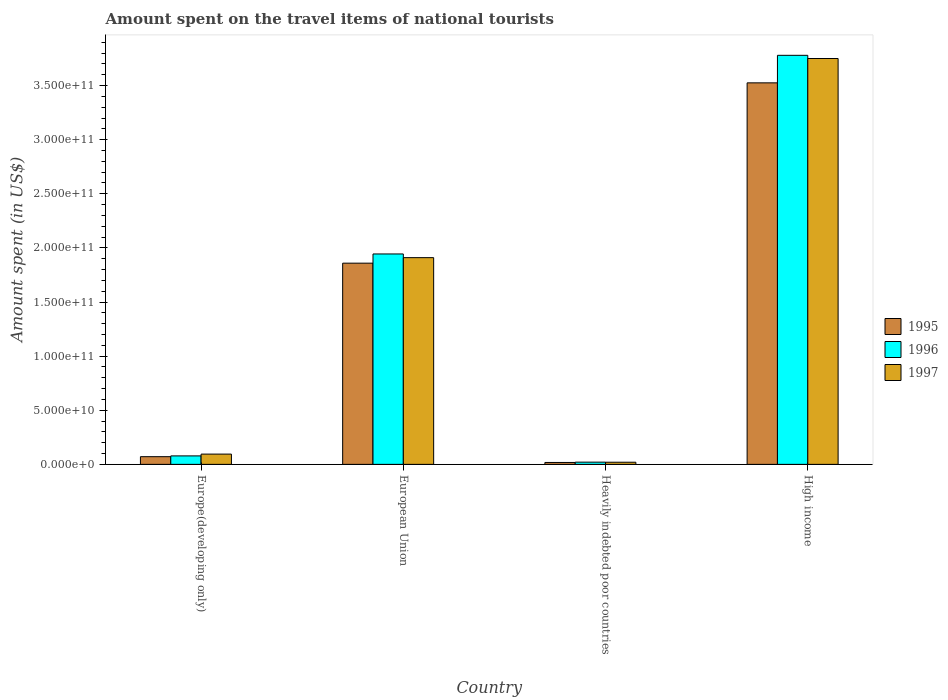How many different coloured bars are there?
Keep it short and to the point. 3. Are the number of bars on each tick of the X-axis equal?
Provide a succinct answer. Yes. How many bars are there on the 4th tick from the left?
Your response must be concise. 3. What is the label of the 1st group of bars from the left?
Offer a terse response. Europe(developing only). What is the amount spent on the travel items of national tourists in 1997 in Europe(developing only)?
Make the answer very short. 9.50e+09. Across all countries, what is the maximum amount spent on the travel items of national tourists in 1997?
Offer a terse response. 3.75e+11. Across all countries, what is the minimum amount spent on the travel items of national tourists in 1997?
Your response must be concise. 1.99e+09. In which country was the amount spent on the travel items of national tourists in 1996 maximum?
Make the answer very short. High income. In which country was the amount spent on the travel items of national tourists in 1996 minimum?
Provide a short and direct response. Heavily indebted poor countries. What is the total amount spent on the travel items of national tourists in 1996 in the graph?
Ensure brevity in your answer.  5.82e+11. What is the difference between the amount spent on the travel items of national tourists in 1996 in Heavily indebted poor countries and that in High income?
Give a very brief answer. -3.76e+11. What is the difference between the amount spent on the travel items of national tourists in 1997 in Europe(developing only) and the amount spent on the travel items of national tourists in 1995 in Heavily indebted poor countries?
Your response must be concise. 7.73e+09. What is the average amount spent on the travel items of national tourists in 1997 per country?
Provide a succinct answer. 1.44e+11. What is the difference between the amount spent on the travel items of national tourists of/in 1995 and amount spent on the travel items of national tourists of/in 1996 in Heavily indebted poor countries?
Your response must be concise. -2.89e+08. What is the ratio of the amount spent on the travel items of national tourists in 1995 in Europe(developing only) to that in European Union?
Offer a very short reply. 0.04. Is the amount spent on the travel items of national tourists in 1997 in Europe(developing only) less than that in Heavily indebted poor countries?
Keep it short and to the point. No. Is the difference between the amount spent on the travel items of national tourists in 1995 in Europe(developing only) and European Union greater than the difference between the amount spent on the travel items of national tourists in 1996 in Europe(developing only) and European Union?
Keep it short and to the point. Yes. What is the difference between the highest and the second highest amount spent on the travel items of national tourists in 1995?
Make the answer very short. -1.67e+11. What is the difference between the highest and the lowest amount spent on the travel items of national tourists in 1996?
Your answer should be compact. 3.76e+11. In how many countries, is the amount spent on the travel items of national tourists in 1997 greater than the average amount spent on the travel items of national tourists in 1997 taken over all countries?
Your answer should be very brief. 2. Is it the case that in every country, the sum of the amount spent on the travel items of national tourists in 1996 and amount spent on the travel items of national tourists in 1997 is greater than the amount spent on the travel items of national tourists in 1995?
Your response must be concise. Yes. How many bars are there?
Provide a succinct answer. 12. Are all the bars in the graph horizontal?
Your response must be concise. No. How many countries are there in the graph?
Provide a short and direct response. 4. Does the graph contain any zero values?
Your response must be concise. No. Where does the legend appear in the graph?
Your answer should be very brief. Center right. How are the legend labels stacked?
Your answer should be very brief. Vertical. What is the title of the graph?
Keep it short and to the point. Amount spent on the travel items of national tourists. Does "1997" appear as one of the legend labels in the graph?
Ensure brevity in your answer.  Yes. What is the label or title of the X-axis?
Offer a very short reply. Country. What is the label or title of the Y-axis?
Give a very brief answer. Amount spent (in US$). What is the Amount spent (in US$) of 1995 in Europe(developing only)?
Give a very brief answer. 7.10e+09. What is the Amount spent (in US$) of 1996 in Europe(developing only)?
Offer a terse response. 7.83e+09. What is the Amount spent (in US$) of 1997 in Europe(developing only)?
Ensure brevity in your answer.  9.50e+09. What is the Amount spent (in US$) in 1995 in European Union?
Provide a short and direct response. 1.86e+11. What is the Amount spent (in US$) of 1996 in European Union?
Your answer should be very brief. 1.94e+11. What is the Amount spent (in US$) in 1997 in European Union?
Provide a succinct answer. 1.91e+11. What is the Amount spent (in US$) of 1995 in Heavily indebted poor countries?
Offer a terse response. 1.77e+09. What is the Amount spent (in US$) in 1996 in Heavily indebted poor countries?
Offer a terse response. 2.06e+09. What is the Amount spent (in US$) in 1997 in Heavily indebted poor countries?
Give a very brief answer. 1.99e+09. What is the Amount spent (in US$) in 1995 in High income?
Make the answer very short. 3.52e+11. What is the Amount spent (in US$) in 1996 in High income?
Keep it short and to the point. 3.78e+11. What is the Amount spent (in US$) of 1997 in High income?
Your response must be concise. 3.75e+11. Across all countries, what is the maximum Amount spent (in US$) in 1995?
Provide a succinct answer. 3.52e+11. Across all countries, what is the maximum Amount spent (in US$) in 1996?
Keep it short and to the point. 3.78e+11. Across all countries, what is the maximum Amount spent (in US$) of 1997?
Your response must be concise. 3.75e+11. Across all countries, what is the minimum Amount spent (in US$) of 1995?
Ensure brevity in your answer.  1.77e+09. Across all countries, what is the minimum Amount spent (in US$) of 1996?
Offer a terse response. 2.06e+09. Across all countries, what is the minimum Amount spent (in US$) of 1997?
Provide a short and direct response. 1.99e+09. What is the total Amount spent (in US$) in 1995 in the graph?
Your response must be concise. 5.47e+11. What is the total Amount spent (in US$) of 1996 in the graph?
Your answer should be compact. 5.82e+11. What is the total Amount spent (in US$) of 1997 in the graph?
Your response must be concise. 5.77e+11. What is the difference between the Amount spent (in US$) of 1995 in Europe(developing only) and that in European Union?
Your answer should be compact. -1.79e+11. What is the difference between the Amount spent (in US$) of 1996 in Europe(developing only) and that in European Union?
Your answer should be very brief. -1.87e+11. What is the difference between the Amount spent (in US$) of 1997 in Europe(developing only) and that in European Union?
Provide a short and direct response. -1.81e+11. What is the difference between the Amount spent (in US$) of 1995 in Europe(developing only) and that in Heavily indebted poor countries?
Your answer should be compact. 5.34e+09. What is the difference between the Amount spent (in US$) of 1996 in Europe(developing only) and that in Heavily indebted poor countries?
Give a very brief answer. 5.77e+09. What is the difference between the Amount spent (in US$) of 1997 in Europe(developing only) and that in Heavily indebted poor countries?
Your response must be concise. 7.51e+09. What is the difference between the Amount spent (in US$) of 1995 in Europe(developing only) and that in High income?
Give a very brief answer. -3.45e+11. What is the difference between the Amount spent (in US$) of 1996 in Europe(developing only) and that in High income?
Your answer should be very brief. -3.70e+11. What is the difference between the Amount spent (in US$) of 1997 in Europe(developing only) and that in High income?
Provide a short and direct response. -3.65e+11. What is the difference between the Amount spent (in US$) of 1995 in European Union and that in Heavily indebted poor countries?
Your answer should be compact. 1.84e+11. What is the difference between the Amount spent (in US$) of 1996 in European Union and that in Heavily indebted poor countries?
Your answer should be compact. 1.92e+11. What is the difference between the Amount spent (in US$) of 1997 in European Union and that in Heavily indebted poor countries?
Ensure brevity in your answer.  1.89e+11. What is the difference between the Amount spent (in US$) in 1995 in European Union and that in High income?
Give a very brief answer. -1.67e+11. What is the difference between the Amount spent (in US$) of 1996 in European Union and that in High income?
Give a very brief answer. -1.84e+11. What is the difference between the Amount spent (in US$) in 1997 in European Union and that in High income?
Offer a very short reply. -1.84e+11. What is the difference between the Amount spent (in US$) of 1995 in Heavily indebted poor countries and that in High income?
Give a very brief answer. -3.51e+11. What is the difference between the Amount spent (in US$) in 1996 in Heavily indebted poor countries and that in High income?
Your answer should be compact. -3.76e+11. What is the difference between the Amount spent (in US$) in 1997 in Heavily indebted poor countries and that in High income?
Your response must be concise. -3.73e+11. What is the difference between the Amount spent (in US$) of 1995 in Europe(developing only) and the Amount spent (in US$) of 1996 in European Union?
Give a very brief answer. -1.87e+11. What is the difference between the Amount spent (in US$) in 1995 in Europe(developing only) and the Amount spent (in US$) in 1997 in European Union?
Offer a very short reply. -1.84e+11. What is the difference between the Amount spent (in US$) in 1996 in Europe(developing only) and the Amount spent (in US$) in 1997 in European Union?
Your answer should be very brief. -1.83e+11. What is the difference between the Amount spent (in US$) in 1995 in Europe(developing only) and the Amount spent (in US$) in 1996 in Heavily indebted poor countries?
Provide a succinct answer. 5.05e+09. What is the difference between the Amount spent (in US$) in 1995 in Europe(developing only) and the Amount spent (in US$) in 1997 in Heavily indebted poor countries?
Keep it short and to the point. 5.12e+09. What is the difference between the Amount spent (in US$) in 1996 in Europe(developing only) and the Amount spent (in US$) in 1997 in Heavily indebted poor countries?
Offer a terse response. 5.84e+09. What is the difference between the Amount spent (in US$) of 1995 in Europe(developing only) and the Amount spent (in US$) of 1996 in High income?
Offer a terse response. -3.71e+11. What is the difference between the Amount spent (in US$) of 1995 in Europe(developing only) and the Amount spent (in US$) of 1997 in High income?
Your answer should be very brief. -3.68e+11. What is the difference between the Amount spent (in US$) of 1996 in Europe(developing only) and the Amount spent (in US$) of 1997 in High income?
Your answer should be compact. -3.67e+11. What is the difference between the Amount spent (in US$) of 1995 in European Union and the Amount spent (in US$) of 1996 in Heavily indebted poor countries?
Your response must be concise. 1.84e+11. What is the difference between the Amount spent (in US$) in 1995 in European Union and the Amount spent (in US$) in 1997 in Heavily indebted poor countries?
Offer a very short reply. 1.84e+11. What is the difference between the Amount spent (in US$) of 1996 in European Union and the Amount spent (in US$) of 1997 in Heavily indebted poor countries?
Keep it short and to the point. 1.92e+11. What is the difference between the Amount spent (in US$) in 1995 in European Union and the Amount spent (in US$) in 1996 in High income?
Offer a terse response. -1.92e+11. What is the difference between the Amount spent (in US$) of 1995 in European Union and the Amount spent (in US$) of 1997 in High income?
Keep it short and to the point. -1.89e+11. What is the difference between the Amount spent (in US$) in 1996 in European Union and the Amount spent (in US$) in 1997 in High income?
Keep it short and to the point. -1.81e+11. What is the difference between the Amount spent (in US$) of 1995 in Heavily indebted poor countries and the Amount spent (in US$) of 1996 in High income?
Your answer should be very brief. -3.76e+11. What is the difference between the Amount spent (in US$) of 1995 in Heavily indebted poor countries and the Amount spent (in US$) of 1997 in High income?
Your response must be concise. -3.73e+11. What is the difference between the Amount spent (in US$) in 1996 in Heavily indebted poor countries and the Amount spent (in US$) in 1997 in High income?
Give a very brief answer. -3.73e+11. What is the average Amount spent (in US$) in 1995 per country?
Keep it short and to the point. 1.37e+11. What is the average Amount spent (in US$) in 1996 per country?
Your response must be concise. 1.46e+11. What is the average Amount spent (in US$) in 1997 per country?
Make the answer very short. 1.44e+11. What is the difference between the Amount spent (in US$) of 1995 and Amount spent (in US$) of 1996 in Europe(developing only)?
Keep it short and to the point. -7.25e+08. What is the difference between the Amount spent (in US$) of 1995 and Amount spent (in US$) of 1997 in Europe(developing only)?
Your answer should be compact. -2.39e+09. What is the difference between the Amount spent (in US$) in 1996 and Amount spent (in US$) in 1997 in Europe(developing only)?
Provide a succinct answer. -1.67e+09. What is the difference between the Amount spent (in US$) of 1995 and Amount spent (in US$) of 1996 in European Union?
Your answer should be compact. -8.51e+09. What is the difference between the Amount spent (in US$) of 1995 and Amount spent (in US$) of 1997 in European Union?
Provide a succinct answer. -5.10e+09. What is the difference between the Amount spent (in US$) in 1996 and Amount spent (in US$) in 1997 in European Union?
Offer a terse response. 3.41e+09. What is the difference between the Amount spent (in US$) in 1995 and Amount spent (in US$) in 1996 in Heavily indebted poor countries?
Give a very brief answer. -2.89e+08. What is the difference between the Amount spent (in US$) of 1995 and Amount spent (in US$) of 1997 in Heavily indebted poor countries?
Give a very brief answer. -2.21e+08. What is the difference between the Amount spent (in US$) in 1996 and Amount spent (in US$) in 1997 in Heavily indebted poor countries?
Your answer should be very brief. 6.82e+07. What is the difference between the Amount spent (in US$) in 1995 and Amount spent (in US$) in 1996 in High income?
Your response must be concise. -2.54e+1. What is the difference between the Amount spent (in US$) in 1995 and Amount spent (in US$) in 1997 in High income?
Provide a succinct answer. -2.25e+1. What is the difference between the Amount spent (in US$) of 1996 and Amount spent (in US$) of 1997 in High income?
Offer a terse response. 2.94e+09. What is the ratio of the Amount spent (in US$) of 1995 in Europe(developing only) to that in European Union?
Provide a short and direct response. 0.04. What is the ratio of the Amount spent (in US$) in 1996 in Europe(developing only) to that in European Union?
Your response must be concise. 0.04. What is the ratio of the Amount spent (in US$) in 1997 in Europe(developing only) to that in European Union?
Offer a terse response. 0.05. What is the ratio of the Amount spent (in US$) of 1995 in Europe(developing only) to that in Heavily indebted poor countries?
Your response must be concise. 4.02. What is the ratio of the Amount spent (in US$) in 1996 in Europe(developing only) to that in Heavily indebted poor countries?
Your answer should be very brief. 3.81. What is the ratio of the Amount spent (in US$) of 1997 in Europe(developing only) to that in Heavily indebted poor countries?
Provide a short and direct response. 4.78. What is the ratio of the Amount spent (in US$) in 1995 in Europe(developing only) to that in High income?
Give a very brief answer. 0.02. What is the ratio of the Amount spent (in US$) in 1996 in Europe(developing only) to that in High income?
Your answer should be very brief. 0.02. What is the ratio of the Amount spent (in US$) of 1997 in Europe(developing only) to that in High income?
Make the answer very short. 0.03. What is the ratio of the Amount spent (in US$) of 1995 in European Union to that in Heavily indebted poor countries?
Ensure brevity in your answer.  105.17. What is the ratio of the Amount spent (in US$) in 1996 in European Union to that in Heavily indebted poor countries?
Keep it short and to the point. 94.53. What is the ratio of the Amount spent (in US$) of 1997 in European Union to that in Heavily indebted poor countries?
Ensure brevity in your answer.  96.05. What is the ratio of the Amount spent (in US$) of 1995 in European Union to that in High income?
Offer a terse response. 0.53. What is the ratio of the Amount spent (in US$) in 1996 in European Union to that in High income?
Ensure brevity in your answer.  0.51. What is the ratio of the Amount spent (in US$) of 1997 in European Union to that in High income?
Make the answer very short. 0.51. What is the ratio of the Amount spent (in US$) in 1995 in Heavily indebted poor countries to that in High income?
Provide a short and direct response. 0.01. What is the ratio of the Amount spent (in US$) in 1996 in Heavily indebted poor countries to that in High income?
Keep it short and to the point. 0.01. What is the ratio of the Amount spent (in US$) in 1997 in Heavily indebted poor countries to that in High income?
Provide a short and direct response. 0.01. What is the difference between the highest and the second highest Amount spent (in US$) of 1995?
Your answer should be very brief. 1.67e+11. What is the difference between the highest and the second highest Amount spent (in US$) in 1996?
Offer a terse response. 1.84e+11. What is the difference between the highest and the second highest Amount spent (in US$) in 1997?
Your answer should be compact. 1.84e+11. What is the difference between the highest and the lowest Amount spent (in US$) in 1995?
Offer a very short reply. 3.51e+11. What is the difference between the highest and the lowest Amount spent (in US$) of 1996?
Provide a succinct answer. 3.76e+11. What is the difference between the highest and the lowest Amount spent (in US$) in 1997?
Give a very brief answer. 3.73e+11. 